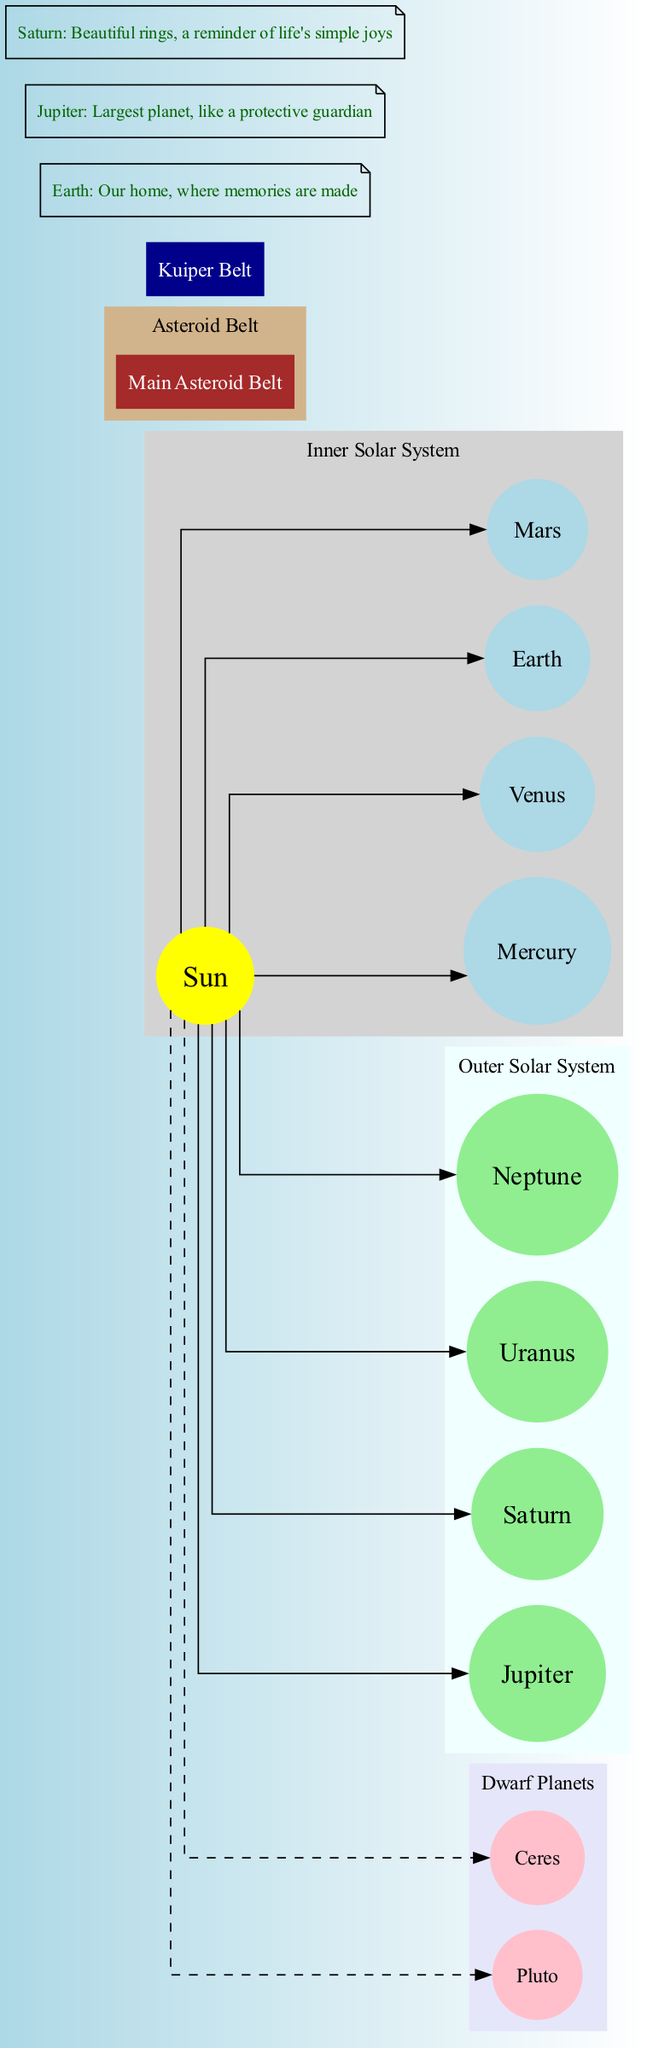What is at the center of the solar system? The diagram indicates that the Sun is in the center, and all other elements are positioned around it.
Answer: Sun How many inner planets are there? By observing the inner solar system section, we see four planets listed: Mercury, Venus, Earth, and Mars.
Answer: 4 Which planet has beautiful rings? The notes section highlights Saturn specifically as the planet known for its beautiful rings.
Answer: Saturn What is the name of the main asteroid belt? The diagram labels the asteroid belt as the "Main Asteroid Belt," which is positioned between the inner and outer planets.
Answer: Main Asteroid Belt How many dwarf planets are shown in the diagram? The diagram lists two dwarf planets: Pluto and Ceres, which can be counted directly from the contacts provided.
Answer: 2 Which region contains Jupiter and Saturn? Referring to the outer solar system part of the diagram, both Jupiter and Saturn are included in that section.
Answer: Outer Solar System What color represents the dwarf planets? The color used for the dwarf planets section in the diagram is pink, as indicated in the cluster subgraph.
Answer: Pink Which is the largest planet in our solar system? In the notes section of the diagram, Jupiter is specifically mentioned as the largest planet.
Answer: Jupiter What distinguishes the Kuiper Belt in the diagram? The Kuiper Belt is distinctly labeled as a box with a dark blue color in the diagram, setting it apart visually from other elements.
Answer: Kuiper Belt 